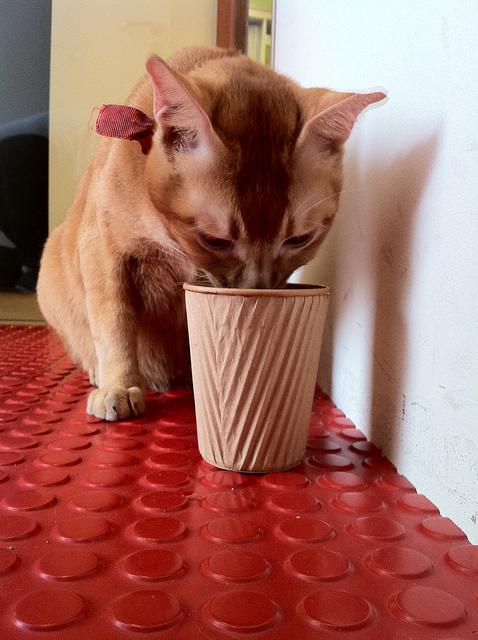Is there a cup?
Short answer required. Yes. What is likely to happen to this container?
Quick response, please. Tipped. What animal is drinking out of the cup?
Be succinct. Cat. 